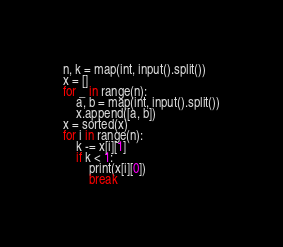Convert code to text. <code><loc_0><loc_0><loc_500><loc_500><_Python_>n, k = map(int, input().split())
x = []
for _ in range(n):
    a, b = map(int, input().split())
    x.append([a, b])
x = sorted(x)
for i in range(n):
    k -= x[i][1]
    if k < 1:
        print(x[i][0])
        break
</code> 